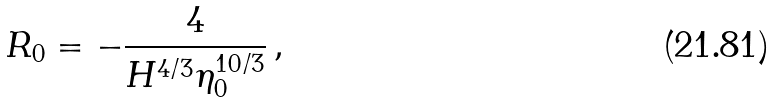Convert formula to latex. <formula><loc_0><loc_0><loc_500><loc_500>R _ { 0 } = - \frac { 4 } { H ^ { 4 / 3 } \eta _ { 0 } ^ { 1 0 / 3 } } \, ,</formula> 